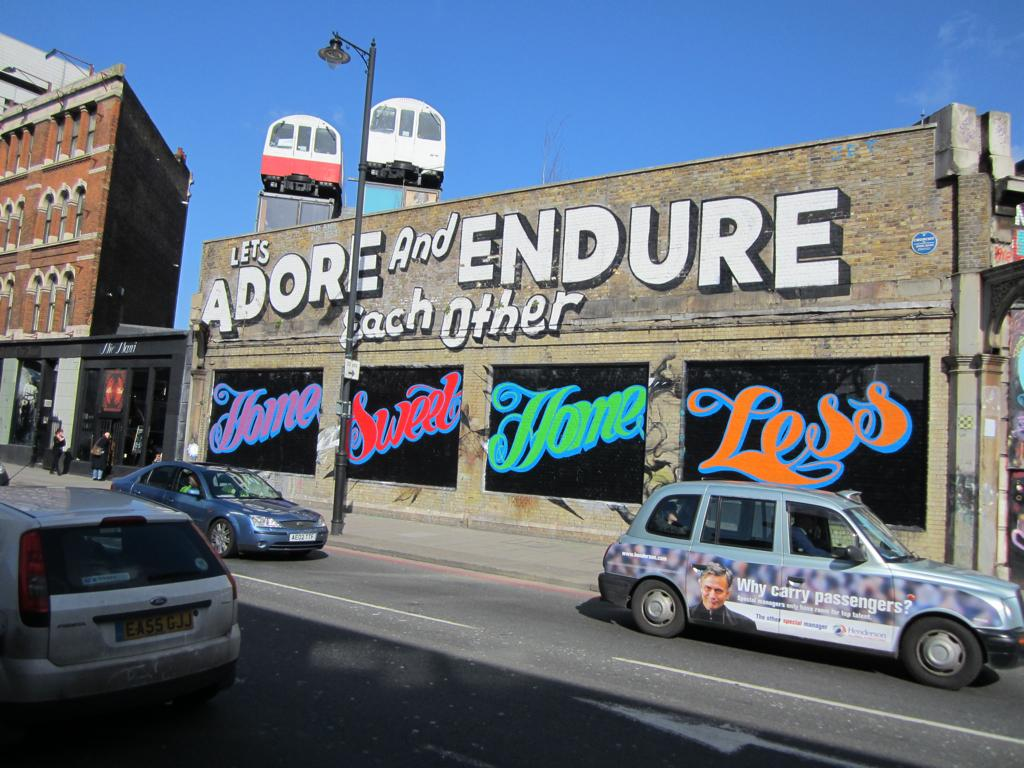<image>
Offer a succinct explanation of the picture presented. A building with a large text saying let's adore and endure each other displayed on the top of the building. 